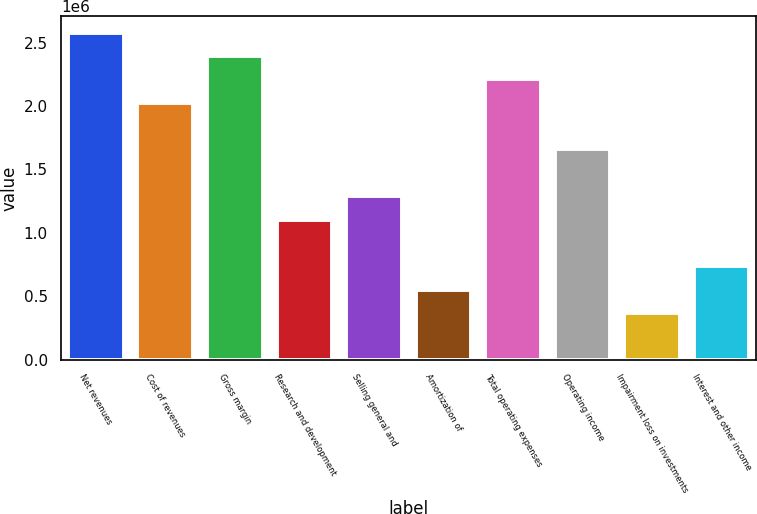Convert chart to OTSL. <chart><loc_0><loc_0><loc_500><loc_500><bar_chart><fcel>Net revenues<fcel>Cost of revenues<fcel>Gross margin<fcel>Research and development<fcel>Selling general and<fcel>Amortization of<fcel>Total operating expenses<fcel>Operating income<fcel>Impairment loss on investments<fcel>Interest and other income<nl><fcel>2.57792e+06<fcel>2.02551e+06<fcel>2.39378e+06<fcel>1.10482e+06<fcel>1.28896e+06<fcel>552412<fcel>2.20965e+06<fcel>1.65723e+06<fcel>368275<fcel>736550<nl></chart> 